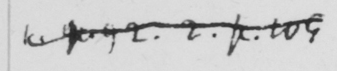Can you read and transcribe this handwriting? <gap/>  p 92 . 2 . p.109 .  .  .  . 